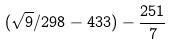Convert formula to latex. <formula><loc_0><loc_0><loc_500><loc_500>( \sqrt { 9 } / 2 9 8 - 4 3 3 ) - \frac { 2 5 1 } { 7 }</formula> 